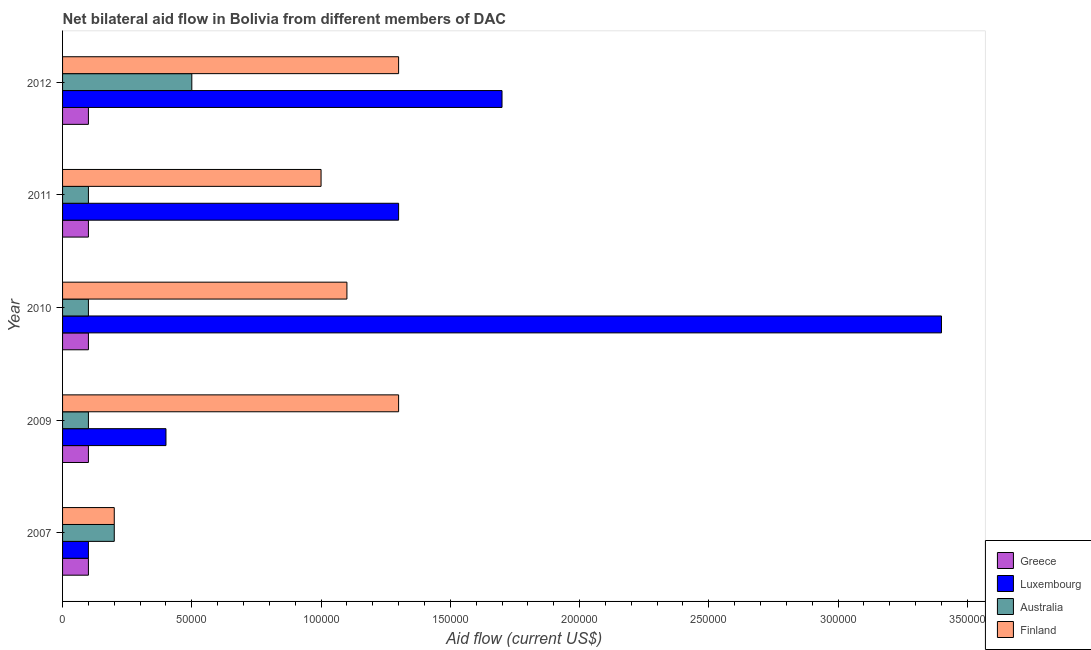Are the number of bars per tick equal to the number of legend labels?
Offer a very short reply. Yes. How many bars are there on the 4th tick from the top?
Offer a terse response. 4. What is the label of the 4th group of bars from the top?
Make the answer very short. 2009. What is the amount of aid given by greece in 2007?
Provide a succinct answer. 10000. Across all years, what is the maximum amount of aid given by finland?
Keep it short and to the point. 1.30e+05. Across all years, what is the minimum amount of aid given by australia?
Provide a succinct answer. 10000. In which year was the amount of aid given by australia maximum?
Ensure brevity in your answer.  2012. In which year was the amount of aid given by luxembourg minimum?
Ensure brevity in your answer.  2007. What is the total amount of aid given by australia in the graph?
Your answer should be very brief. 1.00e+05. What is the difference between the amount of aid given by greece in 2010 and that in 2011?
Offer a terse response. 0. What is the difference between the amount of aid given by luxembourg in 2012 and the amount of aid given by greece in 2010?
Give a very brief answer. 1.60e+05. What is the average amount of aid given by australia per year?
Ensure brevity in your answer.  2.00e+04. In the year 2010, what is the difference between the amount of aid given by greece and amount of aid given by luxembourg?
Your answer should be very brief. -3.30e+05. In how many years, is the amount of aid given by finland greater than 340000 US$?
Give a very brief answer. 0. What is the ratio of the amount of aid given by finland in 2007 to that in 2012?
Provide a short and direct response. 0.15. Is the amount of aid given by luxembourg in 2007 less than that in 2011?
Offer a very short reply. Yes. What is the difference between the highest and the lowest amount of aid given by greece?
Make the answer very short. 0. Is the sum of the amount of aid given by australia in 2007 and 2011 greater than the maximum amount of aid given by finland across all years?
Offer a very short reply. No. Is it the case that in every year, the sum of the amount of aid given by greece and amount of aid given by australia is greater than the sum of amount of aid given by finland and amount of aid given by luxembourg?
Provide a succinct answer. No. Is it the case that in every year, the sum of the amount of aid given by greece and amount of aid given by luxembourg is greater than the amount of aid given by australia?
Keep it short and to the point. No. How many years are there in the graph?
Provide a succinct answer. 5. Are the values on the major ticks of X-axis written in scientific E-notation?
Provide a short and direct response. No. How many legend labels are there?
Give a very brief answer. 4. What is the title of the graph?
Your answer should be very brief. Net bilateral aid flow in Bolivia from different members of DAC. Does "Fish species" appear as one of the legend labels in the graph?
Ensure brevity in your answer.  No. What is the label or title of the X-axis?
Provide a succinct answer. Aid flow (current US$). What is the label or title of the Y-axis?
Your answer should be very brief. Year. What is the Aid flow (current US$) in Finland in 2007?
Provide a short and direct response. 2.00e+04. What is the Aid flow (current US$) in Greece in 2009?
Give a very brief answer. 10000. What is the Aid flow (current US$) of Luxembourg in 2009?
Offer a very short reply. 4.00e+04. What is the Aid flow (current US$) of Australia in 2009?
Offer a very short reply. 10000. What is the Aid flow (current US$) of Greece in 2010?
Make the answer very short. 10000. What is the Aid flow (current US$) in Luxembourg in 2010?
Offer a terse response. 3.40e+05. What is the Aid flow (current US$) in Finland in 2010?
Ensure brevity in your answer.  1.10e+05. What is the Aid flow (current US$) of Australia in 2011?
Offer a terse response. 10000. What is the Aid flow (current US$) of Australia in 2012?
Keep it short and to the point. 5.00e+04. What is the Aid flow (current US$) in Finland in 2012?
Provide a succinct answer. 1.30e+05. Across all years, what is the maximum Aid flow (current US$) of Australia?
Your response must be concise. 5.00e+04. Across all years, what is the maximum Aid flow (current US$) in Finland?
Make the answer very short. 1.30e+05. Across all years, what is the minimum Aid flow (current US$) in Luxembourg?
Your answer should be very brief. 10000. Across all years, what is the minimum Aid flow (current US$) of Australia?
Your answer should be very brief. 10000. Across all years, what is the minimum Aid flow (current US$) in Finland?
Your answer should be compact. 2.00e+04. What is the total Aid flow (current US$) in Luxembourg in the graph?
Ensure brevity in your answer.  6.90e+05. What is the total Aid flow (current US$) in Finland in the graph?
Ensure brevity in your answer.  4.90e+05. What is the difference between the Aid flow (current US$) of Greece in 2007 and that in 2009?
Offer a terse response. 0. What is the difference between the Aid flow (current US$) in Luxembourg in 2007 and that in 2009?
Offer a terse response. -3.00e+04. What is the difference between the Aid flow (current US$) in Finland in 2007 and that in 2009?
Provide a succinct answer. -1.10e+05. What is the difference between the Aid flow (current US$) in Greece in 2007 and that in 2010?
Ensure brevity in your answer.  0. What is the difference between the Aid flow (current US$) in Luxembourg in 2007 and that in 2010?
Offer a terse response. -3.30e+05. What is the difference between the Aid flow (current US$) in Australia in 2007 and that in 2010?
Make the answer very short. 10000. What is the difference between the Aid flow (current US$) in Finland in 2007 and that in 2010?
Your answer should be compact. -9.00e+04. What is the difference between the Aid flow (current US$) in Greece in 2007 and that in 2011?
Offer a terse response. 0. What is the difference between the Aid flow (current US$) in Luxembourg in 2007 and that in 2011?
Your answer should be very brief. -1.20e+05. What is the difference between the Aid flow (current US$) in Finland in 2007 and that in 2011?
Keep it short and to the point. -8.00e+04. What is the difference between the Aid flow (current US$) in Greece in 2007 and that in 2012?
Your answer should be very brief. 0. What is the difference between the Aid flow (current US$) of Finland in 2009 and that in 2010?
Give a very brief answer. 2.00e+04. What is the difference between the Aid flow (current US$) in Greece in 2009 and that in 2011?
Keep it short and to the point. 0. What is the difference between the Aid flow (current US$) of Luxembourg in 2009 and that in 2011?
Your answer should be compact. -9.00e+04. What is the difference between the Aid flow (current US$) in Greece in 2009 and that in 2012?
Keep it short and to the point. 0. What is the difference between the Aid flow (current US$) of Luxembourg in 2009 and that in 2012?
Offer a very short reply. -1.30e+05. What is the difference between the Aid flow (current US$) in Finland in 2009 and that in 2012?
Ensure brevity in your answer.  0. What is the difference between the Aid flow (current US$) of Greece in 2010 and that in 2011?
Give a very brief answer. 0. What is the difference between the Aid flow (current US$) of Luxembourg in 2010 and that in 2012?
Your response must be concise. 1.70e+05. What is the difference between the Aid flow (current US$) in Australia in 2010 and that in 2012?
Ensure brevity in your answer.  -4.00e+04. What is the difference between the Aid flow (current US$) in Greece in 2011 and that in 2012?
Offer a terse response. 0. What is the difference between the Aid flow (current US$) of Australia in 2011 and that in 2012?
Provide a succinct answer. -4.00e+04. What is the difference between the Aid flow (current US$) in Luxembourg in 2007 and the Aid flow (current US$) in Finland in 2009?
Your answer should be compact. -1.20e+05. What is the difference between the Aid flow (current US$) of Australia in 2007 and the Aid flow (current US$) of Finland in 2009?
Make the answer very short. -1.10e+05. What is the difference between the Aid flow (current US$) in Greece in 2007 and the Aid flow (current US$) in Luxembourg in 2010?
Your answer should be very brief. -3.30e+05. What is the difference between the Aid flow (current US$) of Luxembourg in 2007 and the Aid flow (current US$) of Australia in 2010?
Make the answer very short. 0. What is the difference between the Aid flow (current US$) of Australia in 2007 and the Aid flow (current US$) of Finland in 2010?
Provide a short and direct response. -9.00e+04. What is the difference between the Aid flow (current US$) in Greece in 2007 and the Aid flow (current US$) in Luxembourg in 2011?
Make the answer very short. -1.20e+05. What is the difference between the Aid flow (current US$) in Greece in 2007 and the Aid flow (current US$) in Australia in 2011?
Offer a terse response. 0. What is the difference between the Aid flow (current US$) in Greece in 2007 and the Aid flow (current US$) in Australia in 2012?
Provide a succinct answer. -4.00e+04. What is the difference between the Aid flow (current US$) of Australia in 2007 and the Aid flow (current US$) of Finland in 2012?
Your response must be concise. -1.10e+05. What is the difference between the Aid flow (current US$) in Greece in 2009 and the Aid flow (current US$) in Luxembourg in 2010?
Make the answer very short. -3.30e+05. What is the difference between the Aid flow (current US$) of Greece in 2009 and the Aid flow (current US$) of Finland in 2010?
Offer a very short reply. -1.00e+05. What is the difference between the Aid flow (current US$) in Luxembourg in 2009 and the Aid flow (current US$) in Australia in 2010?
Make the answer very short. 3.00e+04. What is the difference between the Aid flow (current US$) in Australia in 2009 and the Aid flow (current US$) in Finland in 2010?
Your response must be concise. -1.00e+05. What is the difference between the Aid flow (current US$) in Greece in 2009 and the Aid flow (current US$) in Luxembourg in 2011?
Provide a succinct answer. -1.20e+05. What is the difference between the Aid flow (current US$) in Luxembourg in 2009 and the Aid flow (current US$) in Finland in 2011?
Your answer should be very brief. -6.00e+04. What is the difference between the Aid flow (current US$) in Luxembourg in 2009 and the Aid flow (current US$) in Finland in 2012?
Provide a succinct answer. -9.00e+04. What is the difference between the Aid flow (current US$) in Australia in 2009 and the Aid flow (current US$) in Finland in 2012?
Your answer should be very brief. -1.20e+05. What is the difference between the Aid flow (current US$) in Luxembourg in 2010 and the Aid flow (current US$) in Australia in 2011?
Provide a short and direct response. 3.30e+05. What is the difference between the Aid flow (current US$) in Greece in 2010 and the Aid flow (current US$) in Luxembourg in 2012?
Provide a short and direct response. -1.60e+05. What is the difference between the Aid flow (current US$) of Greece in 2010 and the Aid flow (current US$) of Finland in 2012?
Offer a very short reply. -1.20e+05. What is the difference between the Aid flow (current US$) of Luxembourg in 2010 and the Aid flow (current US$) of Finland in 2012?
Ensure brevity in your answer.  2.10e+05. What is the difference between the Aid flow (current US$) in Greece in 2011 and the Aid flow (current US$) in Luxembourg in 2012?
Your answer should be compact. -1.60e+05. What is the difference between the Aid flow (current US$) in Greece in 2011 and the Aid flow (current US$) in Finland in 2012?
Provide a short and direct response. -1.20e+05. What is the difference between the Aid flow (current US$) in Luxembourg in 2011 and the Aid flow (current US$) in Australia in 2012?
Offer a terse response. 8.00e+04. What is the difference between the Aid flow (current US$) in Australia in 2011 and the Aid flow (current US$) in Finland in 2012?
Offer a terse response. -1.20e+05. What is the average Aid flow (current US$) of Luxembourg per year?
Offer a very short reply. 1.38e+05. What is the average Aid flow (current US$) of Finland per year?
Your answer should be compact. 9.80e+04. In the year 2007, what is the difference between the Aid flow (current US$) of Greece and Aid flow (current US$) of Luxembourg?
Provide a short and direct response. 0. In the year 2007, what is the difference between the Aid flow (current US$) in Greece and Aid flow (current US$) in Finland?
Your response must be concise. -10000. In the year 2007, what is the difference between the Aid flow (current US$) of Luxembourg and Aid flow (current US$) of Australia?
Make the answer very short. -10000. In the year 2009, what is the difference between the Aid flow (current US$) in Greece and Aid flow (current US$) in Luxembourg?
Your response must be concise. -3.00e+04. In the year 2009, what is the difference between the Aid flow (current US$) of Greece and Aid flow (current US$) of Australia?
Your answer should be compact. 0. In the year 2009, what is the difference between the Aid flow (current US$) of Greece and Aid flow (current US$) of Finland?
Your response must be concise. -1.20e+05. In the year 2010, what is the difference between the Aid flow (current US$) in Greece and Aid flow (current US$) in Luxembourg?
Your response must be concise. -3.30e+05. In the year 2010, what is the difference between the Aid flow (current US$) of Greece and Aid flow (current US$) of Australia?
Offer a very short reply. 0. In the year 2010, what is the difference between the Aid flow (current US$) of Greece and Aid flow (current US$) of Finland?
Offer a very short reply. -1.00e+05. In the year 2011, what is the difference between the Aid flow (current US$) in Greece and Aid flow (current US$) in Finland?
Provide a succinct answer. -9.00e+04. In the year 2011, what is the difference between the Aid flow (current US$) in Luxembourg and Aid flow (current US$) in Australia?
Your answer should be compact. 1.20e+05. In the year 2011, what is the difference between the Aid flow (current US$) of Australia and Aid flow (current US$) of Finland?
Provide a short and direct response. -9.00e+04. In the year 2012, what is the difference between the Aid flow (current US$) of Greece and Aid flow (current US$) of Luxembourg?
Your answer should be compact. -1.60e+05. In the year 2012, what is the difference between the Aid flow (current US$) in Luxembourg and Aid flow (current US$) in Australia?
Ensure brevity in your answer.  1.20e+05. In the year 2012, what is the difference between the Aid flow (current US$) of Australia and Aid flow (current US$) of Finland?
Your answer should be very brief. -8.00e+04. What is the ratio of the Aid flow (current US$) in Greece in 2007 to that in 2009?
Keep it short and to the point. 1. What is the ratio of the Aid flow (current US$) in Luxembourg in 2007 to that in 2009?
Offer a very short reply. 0.25. What is the ratio of the Aid flow (current US$) in Australia in 2007 to that in 2009?
Your answer should be compact. 2. What is the ratio of the Aid flow (current US$) of Finland in 2007 to that in 2009?
Your response must be concise. 0.15. What is the ratio of the Aid flow (current US$) in Luxembourg in 2007 to that in 2010?
Provide a short and direct response. 0.03. What is the ratio of the Aid flow (current US$) in Finland in 2007 to that in 2010?
Offer a terse response. 0.18. What is the ratio of the Aid flow (current US$) of Greece in 2007 to that in 2011?
Make the answer very short. 1. What is the ratio of the Aid flow (current US$) of Luxembourg in 2007 to that in 2011?
Provide a succinct answer. 0.08. What is the ratio of the Aid flow (current US$) in Australia in 2007 to that in 2011?
Offer a terse response. 2. What is the ratio of the Aid flow (current US$) in Finland in 2007 to that in 2011?
Your response must be concise. 0.2. What is the ratio of the Aid flow (current US$) in Luxembourg in 2007 to that in 2012?
Make the answer very short. 0.06. What is the ratio of the Aid flow (current US$) of Finland in 2007 to that in 2012?
Give a very brief answer. 0.15. What is the ratio of the Aid flow (current US$) in Luxembourg in 2009 to that in 2010?
Offer a very short reply. 0.12. What is the ratio of the Aid flow (current US$) in Australia in 2009 to that in 2010?
Offer a terse response. 1. What is the ratio of the Aid flow (current US$) in Finland in 2009 to that in 2010?
Your answer should be compact. 1.18. What is the ratio of the Aid flow (current US$) in Luxembourg in 2009 to that in 2011?
Keep it short and to the point. 0.31. What is the ratio of the Aid flow (current US$) in Luxembourg in 2009 to that in 2012?
Your response must be concise. 0.24. What is the ratio of the Aid flow (current US$) in Australia in 2009 to that in 2012?
Ensure brevity in your answer.  0.2. What is the ratio of the Aid flow (current US$) in Greece in 2010 to that in 2011?
Give a very brief answer. 1. What is the ratio of the Aid flow (current US$) in Luxembourg in 2010 to that in 2011?
Your response must be concise. 2.62. What is the ratio of the Aid flow (current US$) in Australia in 2010 to that in 2011?
Provide a succinct answer. 1. What is the ratio of the Aid flow (current US$) in Finland in 2010 to that in 2011?
Keep it short and to the point. 1.1. What is the ratio of the Aid flow (current US$) of Finland in 2010 to that in 2012?
Provide a short and direct response. 0.85. What is the ratio of the Aid flow (current US$) of Greece in 2011 to that in 2012?
Provide a succinct answer. 1. What is the ratio of the Aid flow (current US$) in Luxembourg in 2011 to that in 2012?
Your answer should be compact. 0.76. What is the ratio of the Aid flow (current US$) of Finland in 2011 to that in 2012?
Keep it short and to the point. 0.77. What is the difference between the highest and the second highest Aid flow (current US$) in Greece?
Provide a short and direct response. 0. What is the difference between the highest and the second highest Aid flow (current US$) in Luxembourg?
Give a very brief answer. 1.70e+05. What is the difference between the highest and the second highest Aid flow (current US$) of Finland?
Ensure brevity in your answer.  0. What is the difference between the highest and the lowest Aid flow (current US$) in Australia?
Give a very brief answer. 4.00e+04. What is the difference between the highest and the lowest Aid flow (current US$) of Finland?
Offer a terse response. 1.10e+05. 